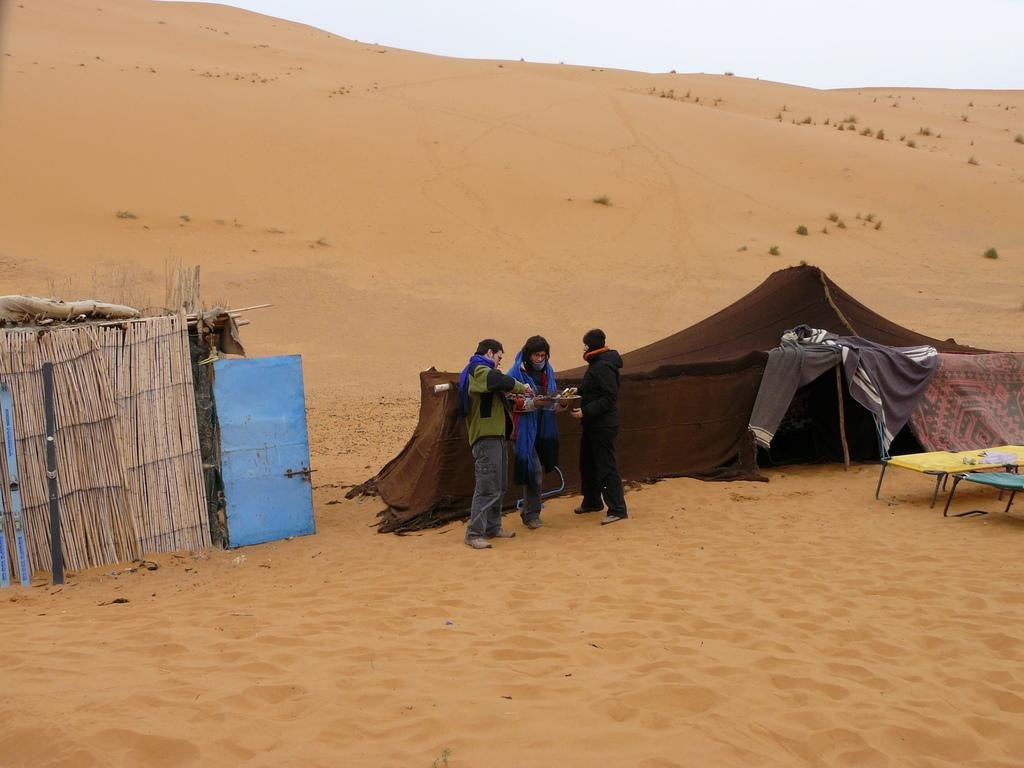What is the surface on which the men are standing in the image? The men are standing on the sand in the image. What type of temporary shelters can be seen in the image? There are tents in the image. What kind of fencing is present in the image? There are thatched fences in the image. What type of vegetation is visible in the image? There are shrubs in the image. What type of sleeping arrangements are present in the image? There are cots in the image. What is visible in the background of the image? The sky is visible in the image. What type of plant is being attacked by the men in the image? There is no plant being attacked in the image, nor are there any men attacking anything. What type of line is visible in the image? There is no line visible in the image. 